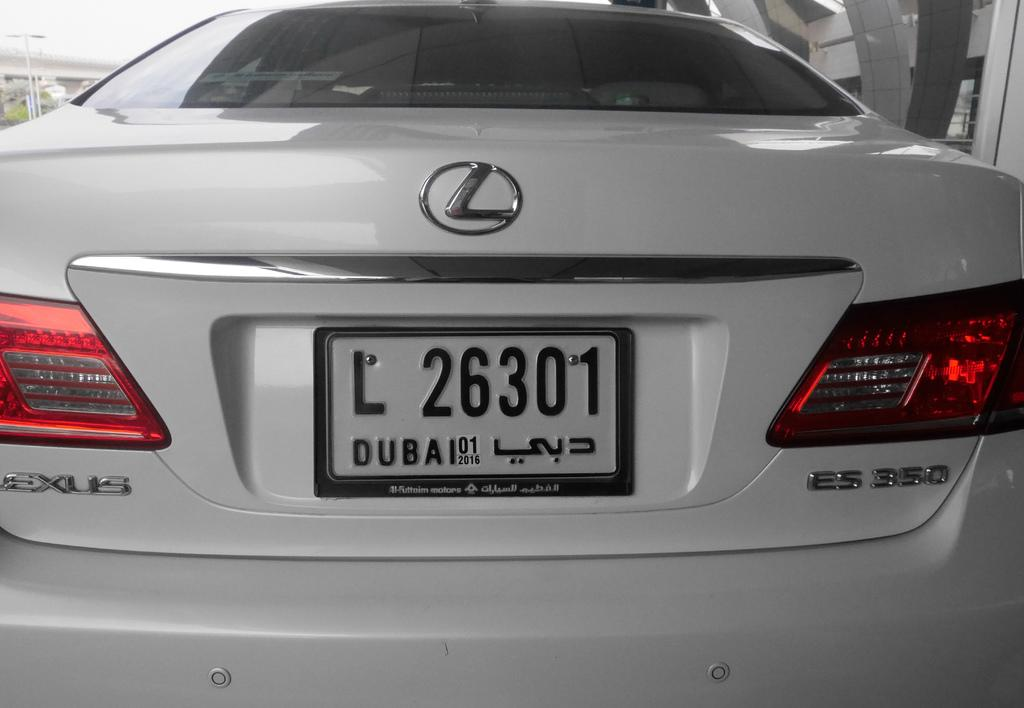<image>
Summarize the visual content of the image. a license platr with the letter L at the start 